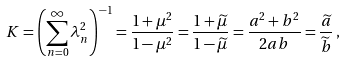Convert formula to latex. <formula><loc_0><loc_0><loc_500><loc_500>K = \left ( \sum _ { n = 0 } ^ { \infty } \lambda _ { n } ^ { 2 } \right ) ^ { - 1 } = \frac { 1 + \mu ^ { 2 } } { 1 - \mu ^ { 2 } } = \frac { 1 + { \widetilde { \mu } } } { 1 - { \widetilde { \mu } } } = \frac { a ^ { 2 } + b ^ { 2 } } { 2 a b } = \frac { \widetilde { a } } { \widetilde { b } } \, ,</formula> 